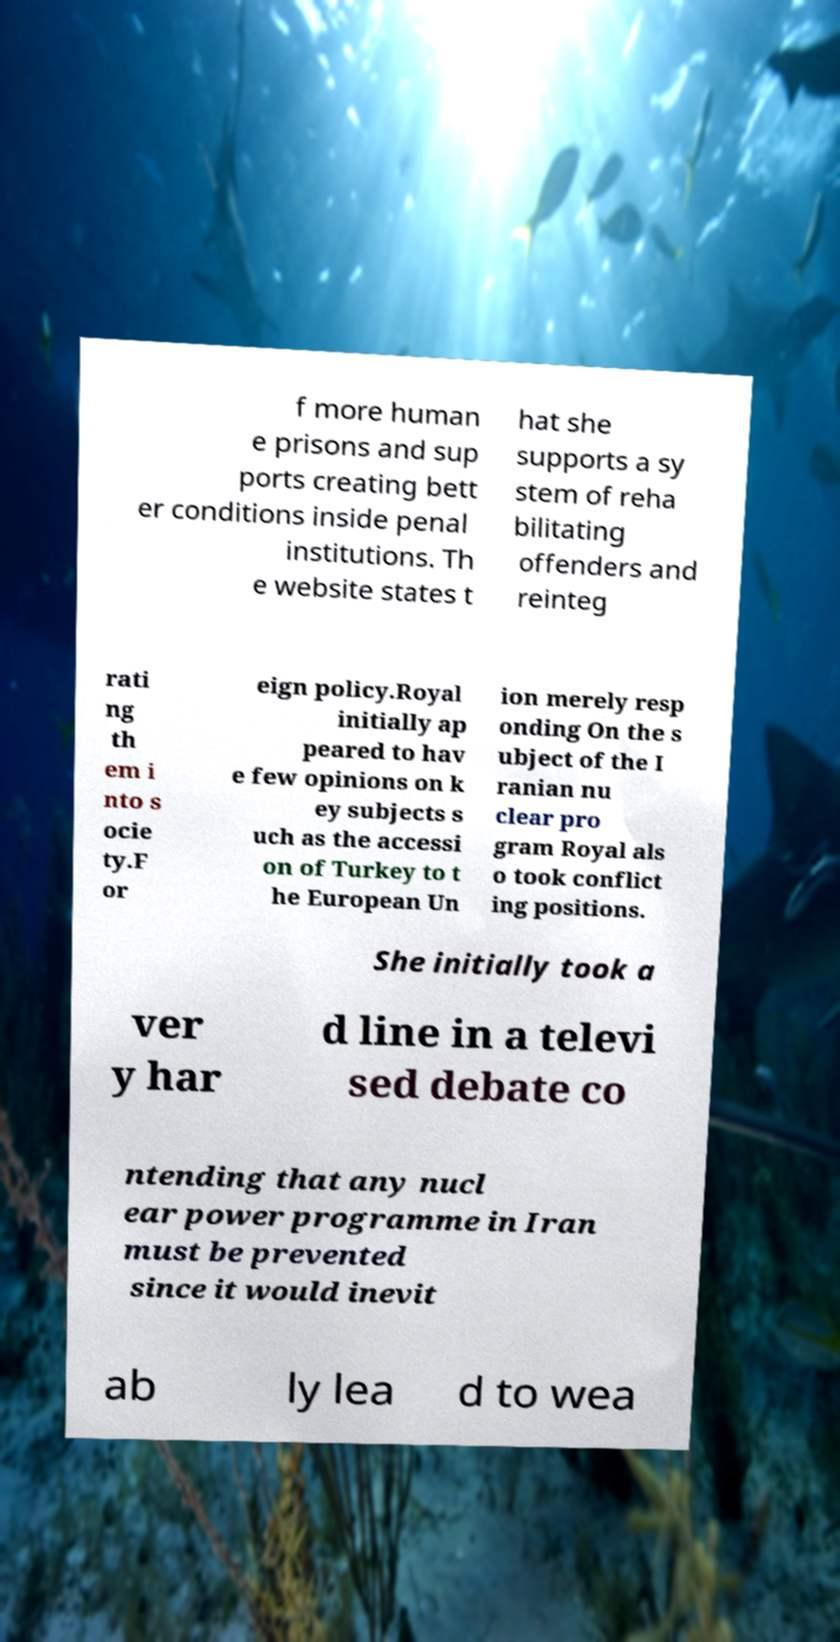I need the written content from this picture converted into text. Can you do that? f more human e prisons and sup ports creating bett er conditions inside penal institutions. Th e website states t hat she supports a sy stem of reha bilitating offenders and reinteg rati ng th em i nto s ocie ty.F or eign policy.Royal initially ap peared to hav e few opinions on k ey subjects s uch as the accessi on of Turkey to t he European Un ion merely resp onding On the s ubject of the I ranian nu clear pro gram Royal als o took conflict ing positions. She initially took a ver y har d line in a televi sed debate co ntending that any nucl ear power programme in Iran must be prevented since it would inevit ab ly lea d to wea 